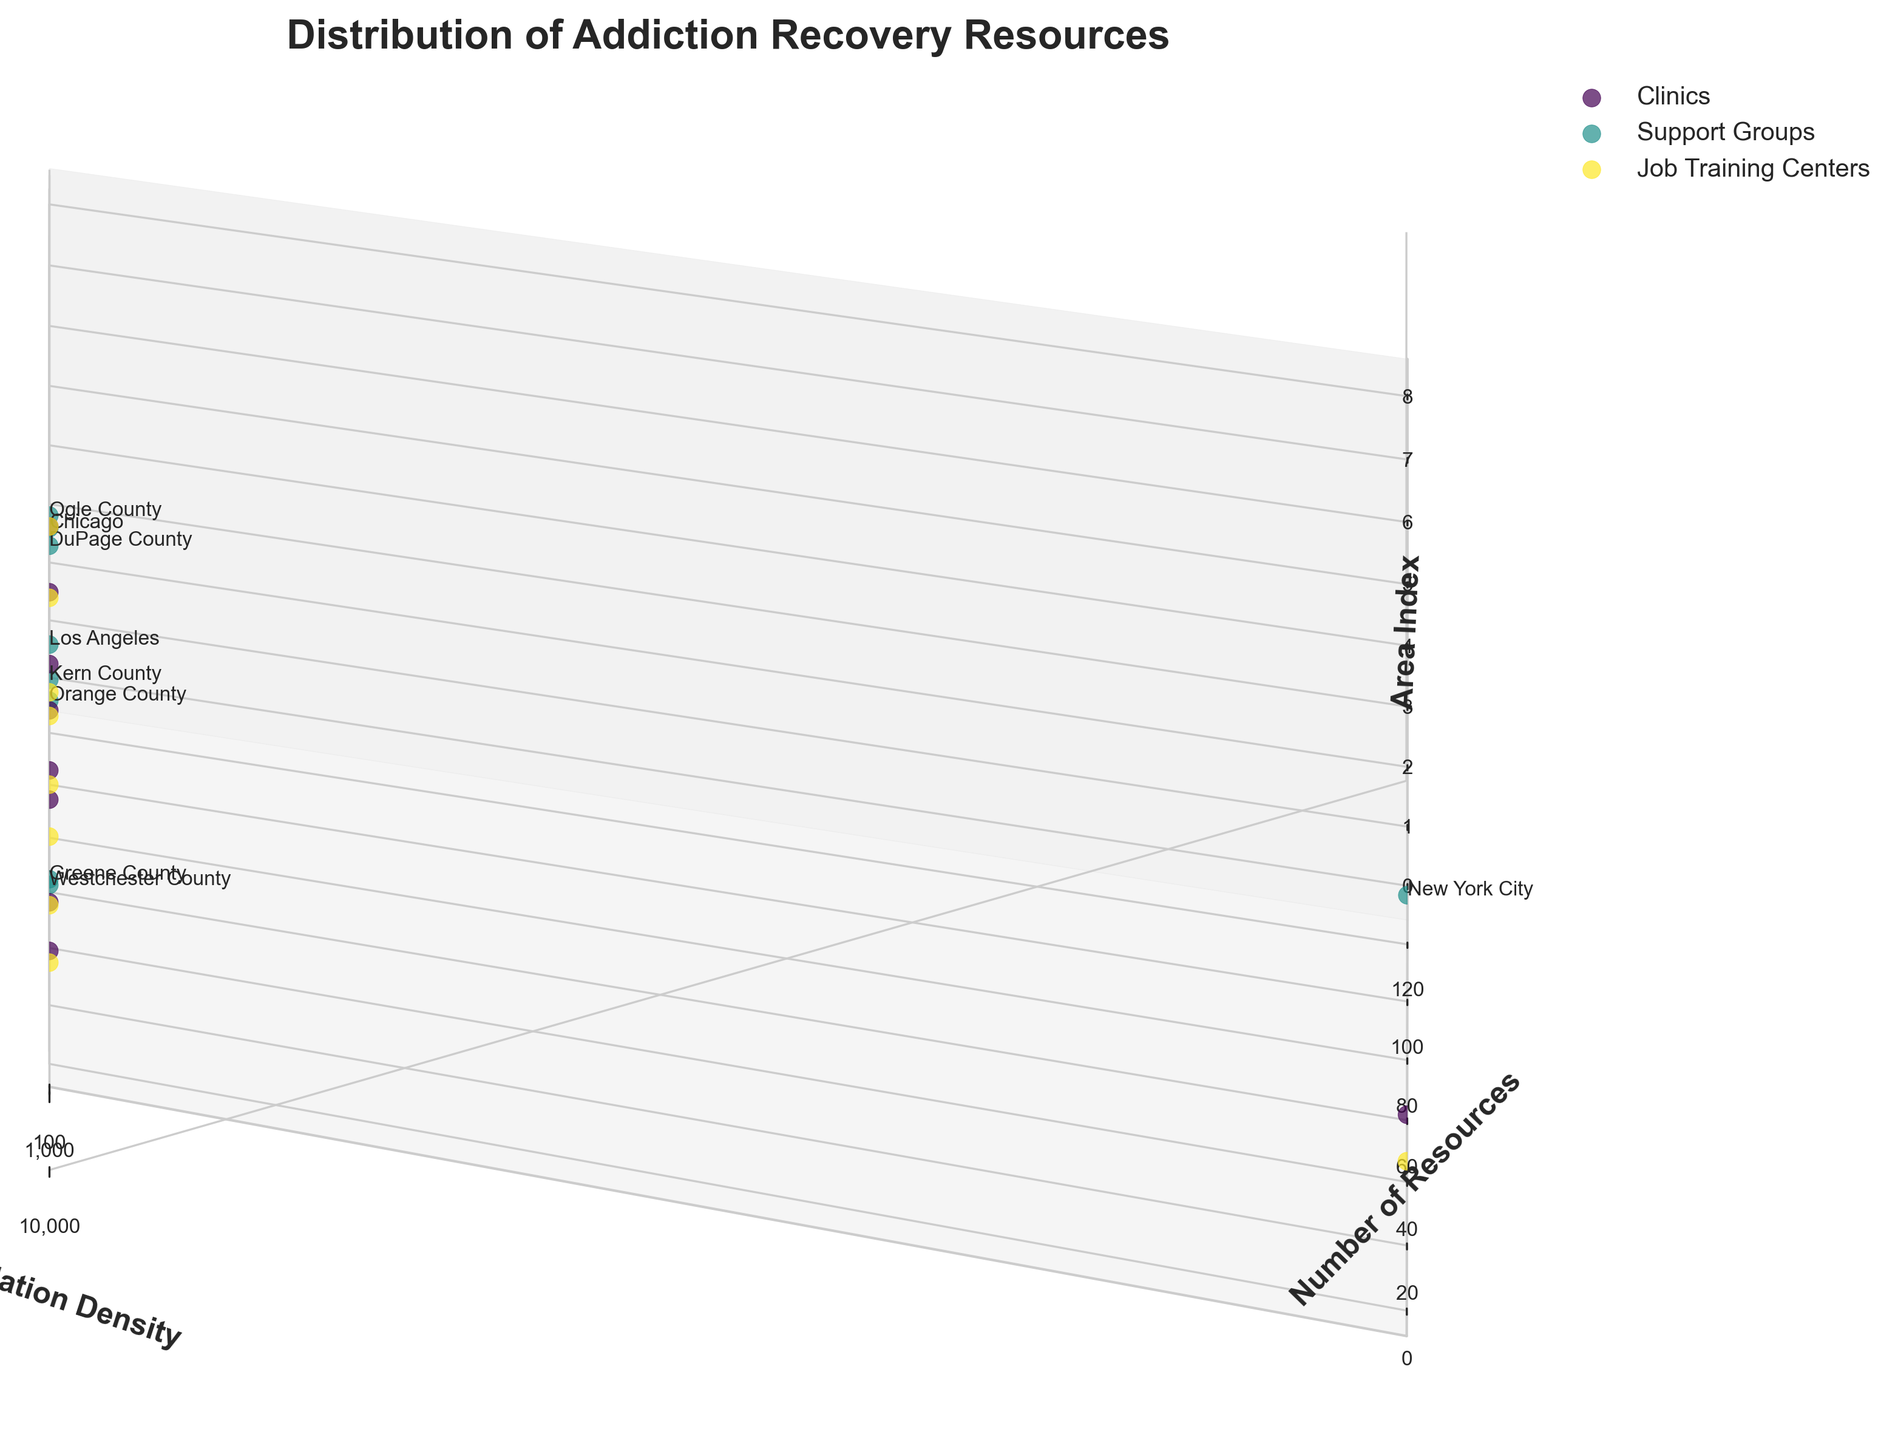what is the title of the plot? The title of the plot is typically displayed at the top and provides a summary of what the figure is about. In this case, it reads "Distribution of Addiction Recovery Resources".
Answer: Distribution of Addiction Recovery Resources What are the labels for the axes? Axis labels describe what each axis represents. Here, the x-axis represents "Population Density", the y-axis represents "Number of Resources", and the z-axis label is "Area Index".
Answer: Population Density, Number of Resources, Area Index Which type of recovery resource is represented by the color closest to blue? The colors in the plot represent different resource types. By looking at the legend, we can identify the resource type linked to the color closest to blue.
Answer: Clinics Which urban area has the highest number of support groups? Urban areas are characterized by a high population density. The plot shows New York City, Los Angeles, and Chicago as urban areas. Among them, we can look for the area with the highest number of support groups.
Answer: New York City How does the number of clinics in suburban areas compare to rural areas? Suburban areas typically have a moderate population density. Checking areas like Westchester County, Orange County, and DuPage County (suburban) against Greene County, Kern County, and Ogle County (rural) can provide insights. By examining the height on the y-axis, we can compare the number of clinics.
Answer: More in suburban than rural In which area do job training centers have the least presence? To find this, look for the area with the lowest point on the Job Training Centers' line. This will be a rural area with the least resources.
Answer: Greene County How many total support groups are there in all the rural areas combined? Summarize the number of support groups from Greene County, Kern County, and Ogle County to get the total. Each rural area's number of support groups must be added together.
Answer: 30 Compare the average number of resources for each type in urban areas. First, identify each urban area (New York City, Los Angeles, Chicago). Sum the resources for each type in these areas and then divide by the number of urban areas to get the average.
Answer: Clinics: 37.67, Support Groups: 98.33, Job Training Centers: 25 Which area has the highest density of resources per population density unit? Calculate the ratio of the number of resources to population density for each area. The area with the highest ratio will have the highest density of resources per unit of population density.
Answer: Ogle County Is there a relationship between population density and the number of resources? Examine the general trend in the scatter plot. If areas with higher population densities align with a higher number of resources, there might be a positive relationship.
Answer: Yes, a positive relationship 